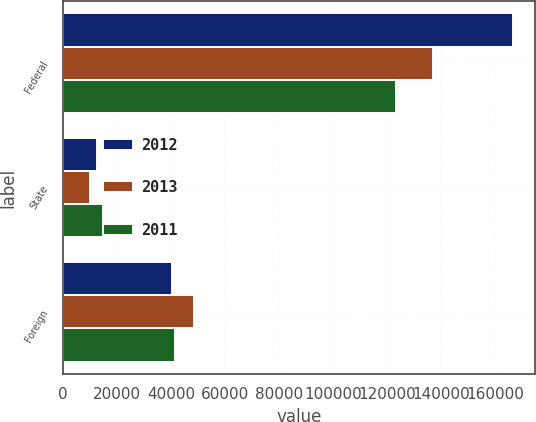Convert chart to OTSL. <chart><loc_0><loc_0><loc_500><loc_500><stacked_bar_chart><ecel><fcel>Federal<fcel>State<fcel>Foreign<nl><fcel>2012<fcel>166430<fcel>12577<fcel>40451<nl><fcel>2013<fcel>136860<fcel>9972<fcel>48403<nl><fcel>2011<fcel>123310<fcel>14903<fcel>41437<nl></chart> 